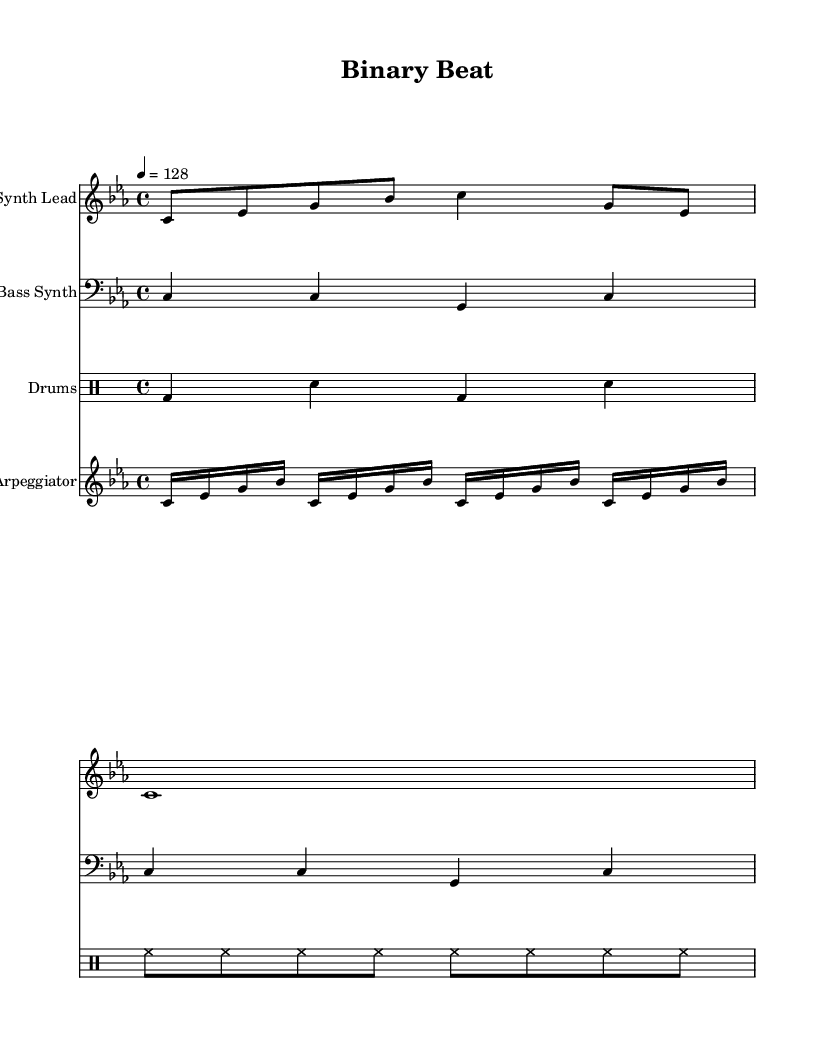What is the key signature of this music? The key signature is C minor, which has three flats (B♭, E♭, A♭). This is deduced from the global definitions at the beginning of the score.
Answer: C minor What is the time signature of this music? The time signature is 4/4, which means there are four beats in a measure and a quarter note receives one beat. This is indicated in the global settings.
Answer: 4/4 What is the tempo marking for this dance piece? The tempo marking indicates the piece should be played at 128 beats per minute. This is specified in the global section of the score as "4 = 128".
Answer: 128 How many measures does the Synth Lead part have? The Synth Lead part consists of 2 measures. The first measure contains activity with notes, and the second one is a whole note, together they equal two measures.
Answer: 2 What rhythmic pattern is used in the drum section? The drum pattern consists of a bass drum and snare alternating in the first measure followed by a continuous hi-hat pattern in the second measure. This can be identified by analyzing the drum pattern notations in the score.
Answer: Bass drum, snare, hi-hat How many times is the arpeggiator sequence repeated? The arpeggiator sequence is repeated 4 times as indicated by the "repeat unfold 4" directive in the section for the arpeggiator part.
Answer: 4 What is the main characteristic of the bass synth part? The bass synth part uses whole notes exclusively to establish a solid foundation which is a common feature in dance music. This can be determined by examining the note values used for the bass synth.
Answer: Whole notes 